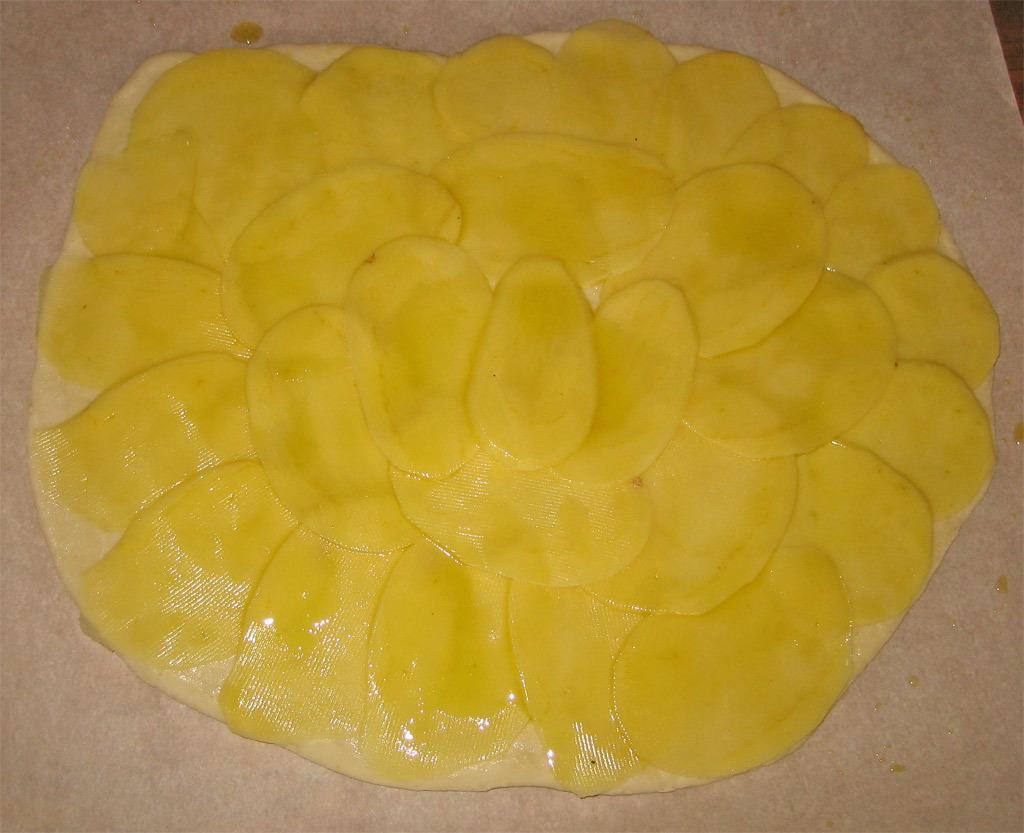In one or two sentences, can you explain what this image depicts? In this image I can see the cream colored surface and on the cream colored surface I can see a yellow colored thing. 